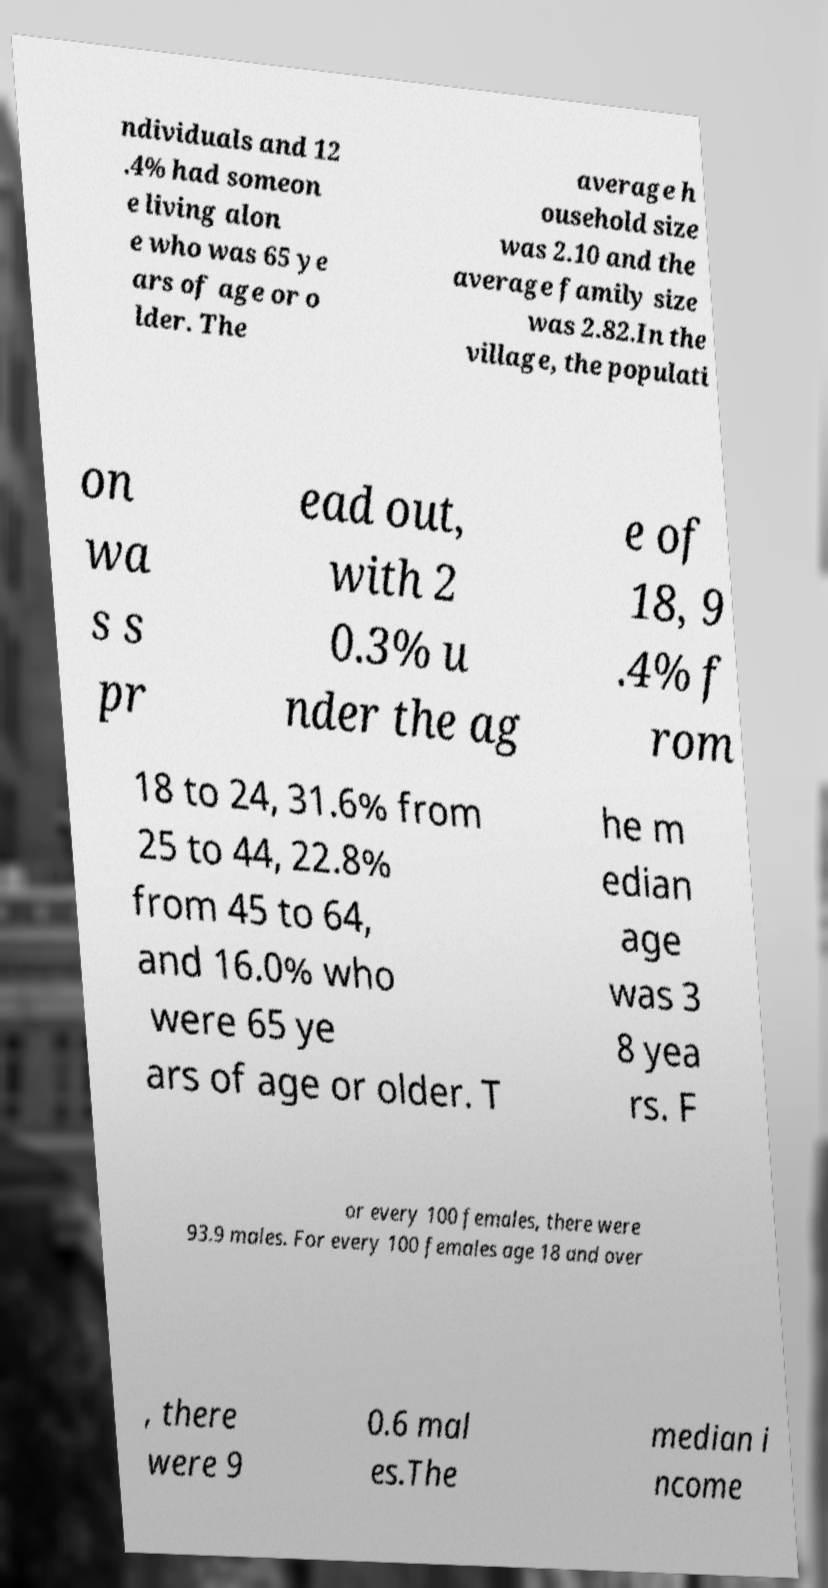For documentation purposes, I need the text within this image transcribed. Could you provide that? ndividuals and 12 .4% had someon e living alon e who was 65 ye ars of age or o lder. The average h ousehold size was 2.10 and the average family size was 2.82.In the village, the populati on wa s s pr ead out, with 2 0.3% u nder the ag e of 18, 9 .4% f rom 18 to 24, 31.6% from 25 to 44, 22.8% from 45 to 64, and 16.0% who were 65 ye ars of age or older. T he m edian age was 3 8 yea rs. F or every 100 females, there were 93.9 males. For every 100 females age 18 and over , there were 9 0.6 mal es.The median i ncome 